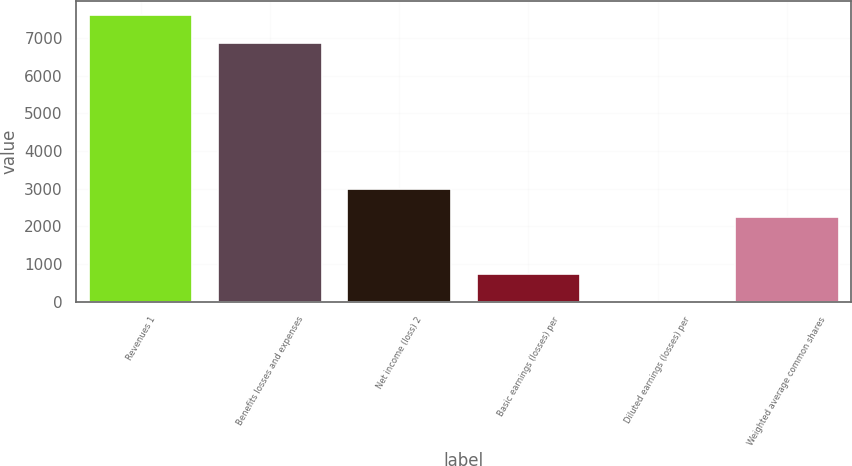Convert chart to OTSL. <chart><loc_0><loc_0><loc_500><loc_500><bar_chart><fcel>Revenues 1<fcel>Benefits losses and expenses<fcel>Net income (loss) 2<fcel>Basic earnings (losses) per<fcel>Diluted earnings (losses) per<fcel>Weighted average common shares<nl><fcel>7601.13<fcel>6851<fcel>3002.25<fcel>751.86<fcel>1.73<fcel>2252.12<nl></chart> 